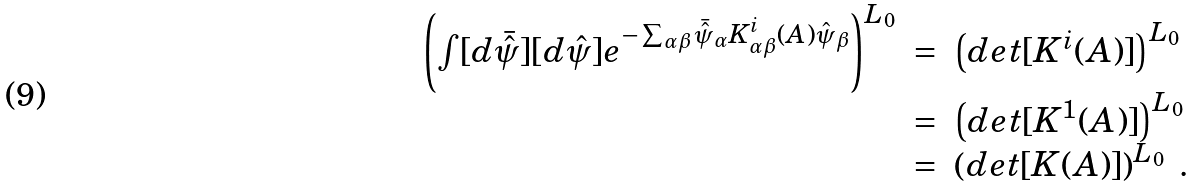<formula> <loc_0><loc_0><loc_500><loc_500>\begin{array} { c c l } \left ( \int [ d \bar { \hat { \psi } } ] [ d \hat { \psi } ] e ^ { - \sum _ { \alpha \beta } \bar { \hat { \psi } } _ { \alpha } K ^ { i } _ { \alpha \beta } ( A ) \hat { \psi } _ { \beta } } \right ) ^ { L _ { 0 } } & = & \left ( d e t [ K ^ { i } ( A ) ] \right ) ^ { L _ { 0 } } \\ & = & \left ( d e t [ K ^ { 1 } ( A ) ] \right ) ^ { L _ { 0 } } \\ & = & \left ( d e t [ K ( A ) ] \right ) ^ { L _ { 0 } } \ . \end{array}</formula> 